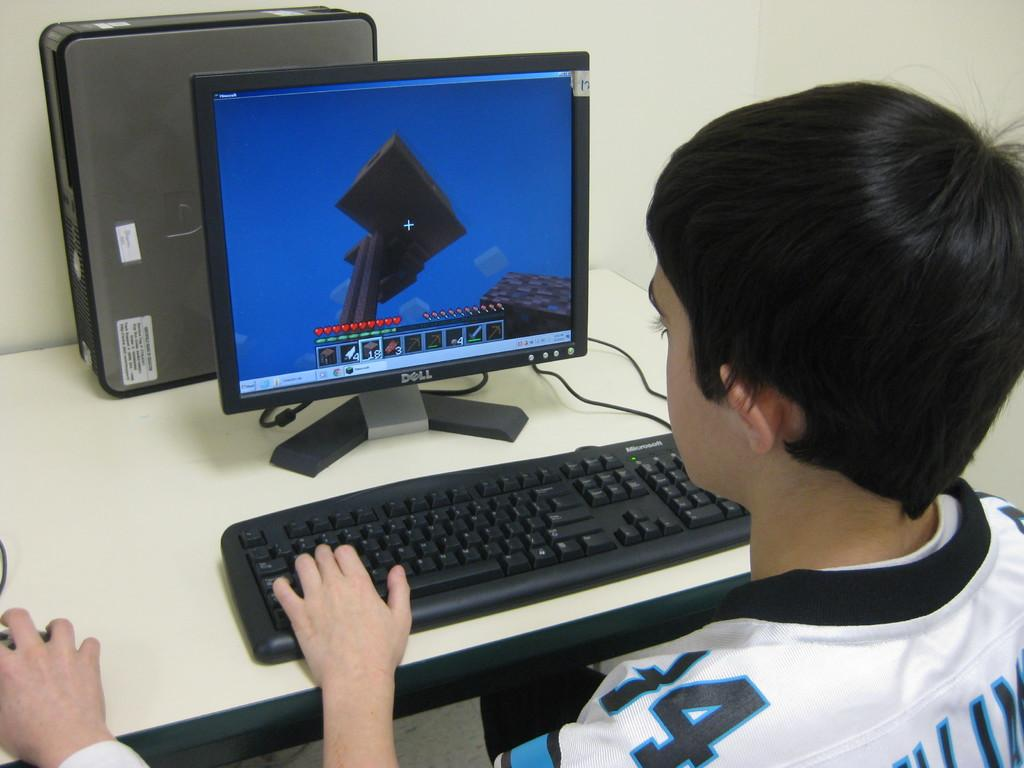<image>
Offer a succinct explanation of the picture presented. A young person plays Minecraft on a Dell monitor with a Microsoft keyboard. 